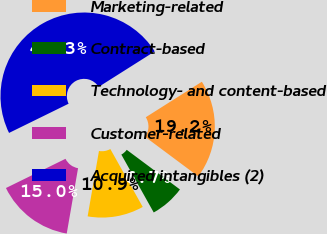Convert chart to OTSL. <chart><loc_0><loc_0><loc_500><loc_500><pie_chart><fcel>Marketing-related<fcel>Contract-based<fcel>Technology- and content-based<fcel>Customer-related<fcel>Acquired intangibles (2)<nl><fcel>19.17%<fcel>6.69%<fcel>10.85%<fcel>15.01%<fcel>48.28%<nl></chart> 